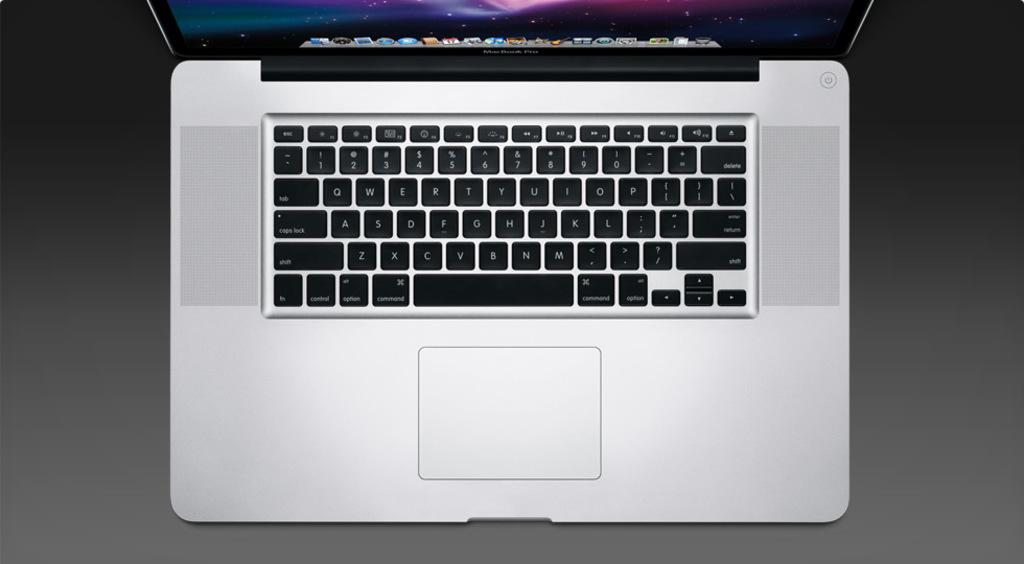<image>
Summarize the visual content of the image. Looking down on an open Macintosh laptop computer 